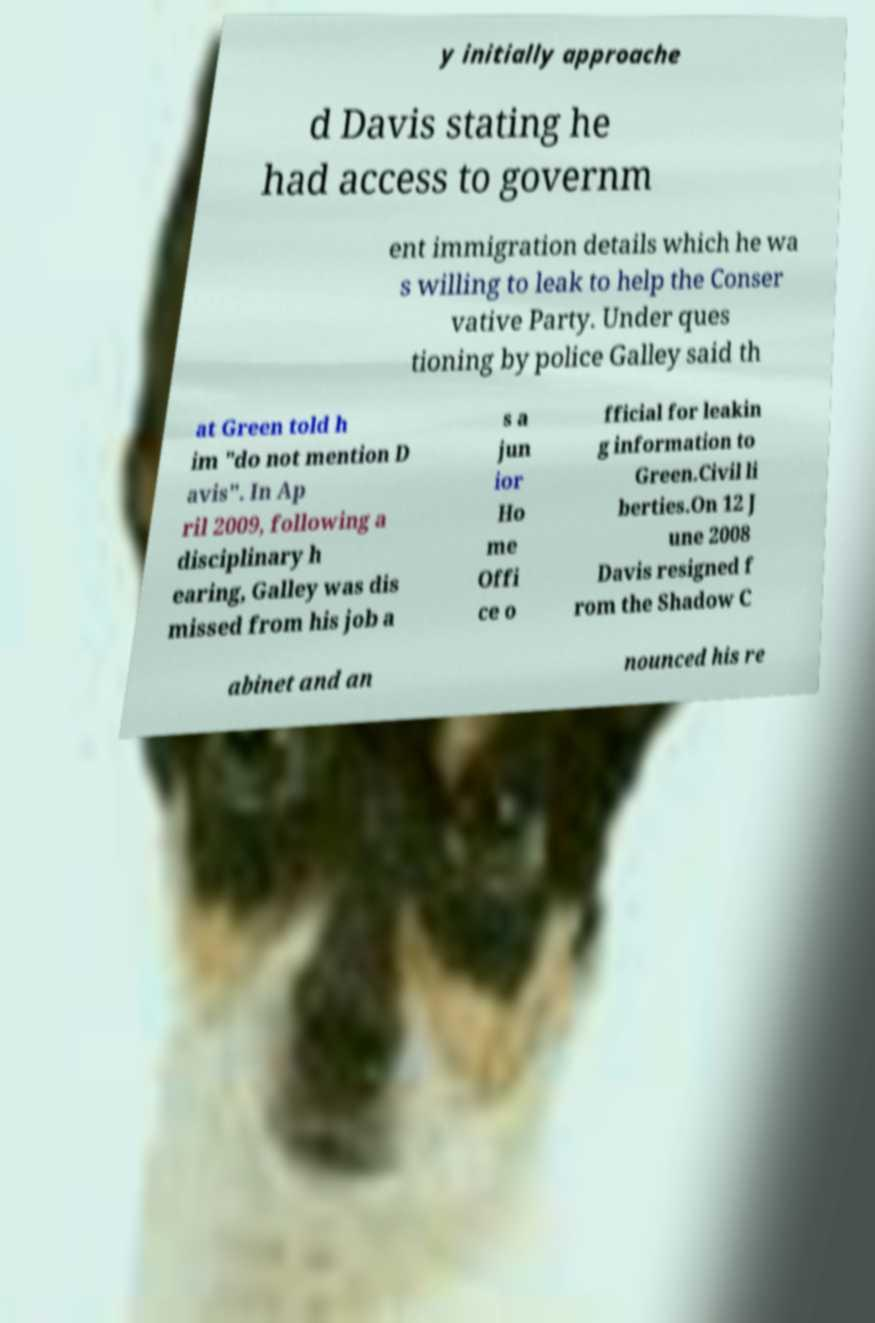Could you assist in decoding the text presented in this image and type it out clearly? y initially approache d Davis stating he had access to governm ent immigration details which he wa s willing to leak to help the Conser vative Party. Under ques tioning by police Galley said th at Green told h im "do not mention D avis". In Ap ril 2009, following a disciplinary h earing, Galley was dis missed from his job a s a jun ior Ho me Offi ce o fficial for leakin g information to Green.Civil li berties.On 12 J une 2008 Davis resigned f rom the Shadow C abinet and an nounced his re 